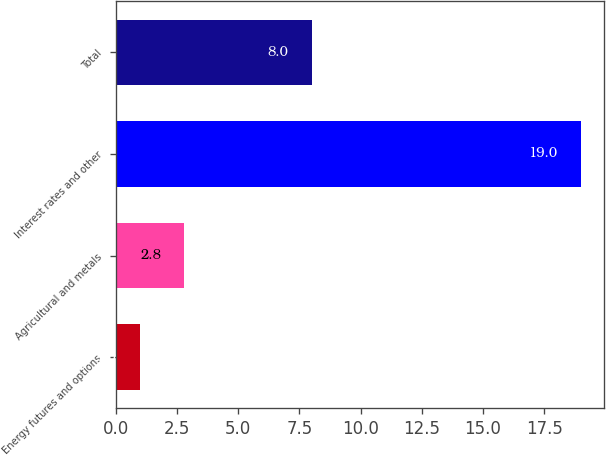Convert chart. <chart><loc_0><loc_0><loc_500><loc_500><bar_chart><fcel>Energy futures and options<fcel>Agricultural and metals<fcel>Interest rates and other<fcel>Total<nl><fcel>1<fcel>2.8<fcel>19<fcel>8<nl></chart> 